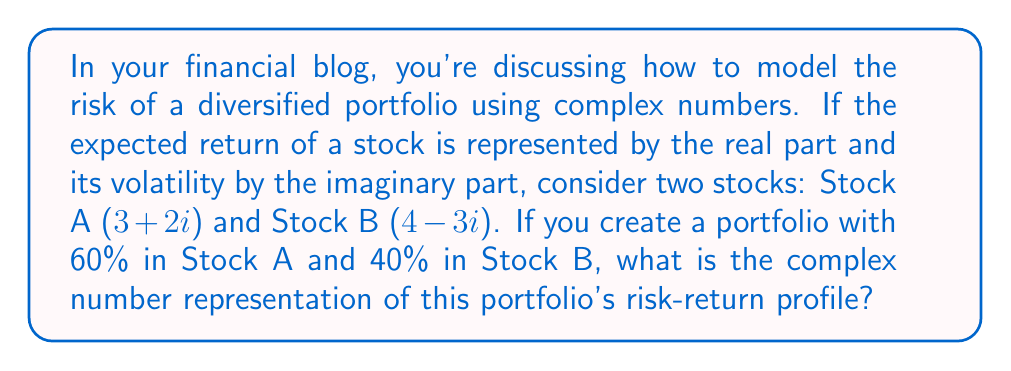Help me with this question. To solve this problem, we'll follow these steps:

1) First, we need to calculate the weighted sum of the two stocks:
   
   Portfolio = 0.6(Stock A) + 0.4(Stock B)

2) Let's substitute the values:
   
   Portfolio = 0.6($3 + 2i$) + 0.4($4 - 3i$)

3) Now, let's distribute the weights:
   
   Portfolio = ($1.8 + 1.2i$) + ($1.6 - 1.2i$)

4) To add these complex numbers, we add the real and imaginary parts separately:
   
   Real part: $1.8 + 1.6 = 3.4$
   Imaginary part: $1.2i - 1.2i = 0i$

5) Therefore, the portfolio can be represented as:
   
   Portfolio = $3.4 + 0i$

This result means that the expected return of the portfolio is 3.4 (the real part), and the volatility is 0 (the imaginary part). The zero volatility suggests that, in this simplified model, the risks of the two stocks perfectly cancel each other out in the given proportion.
Answer: $3.4 + 0i$ 